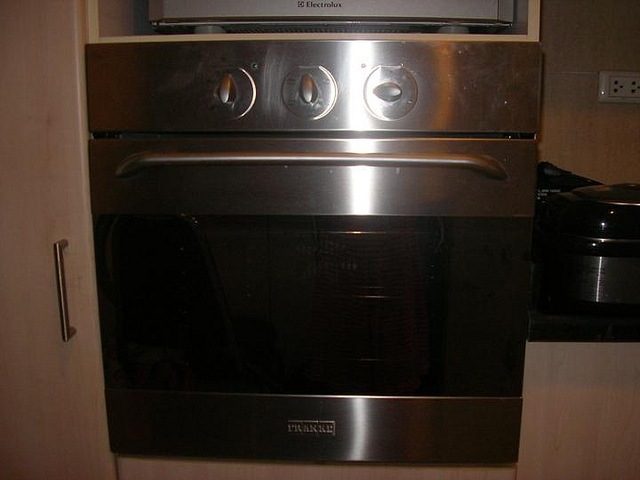<image>Is this oven workable? I'm not sure if the oven is workable without more information. Is this oven workable? I don't know if this oven is workable. 